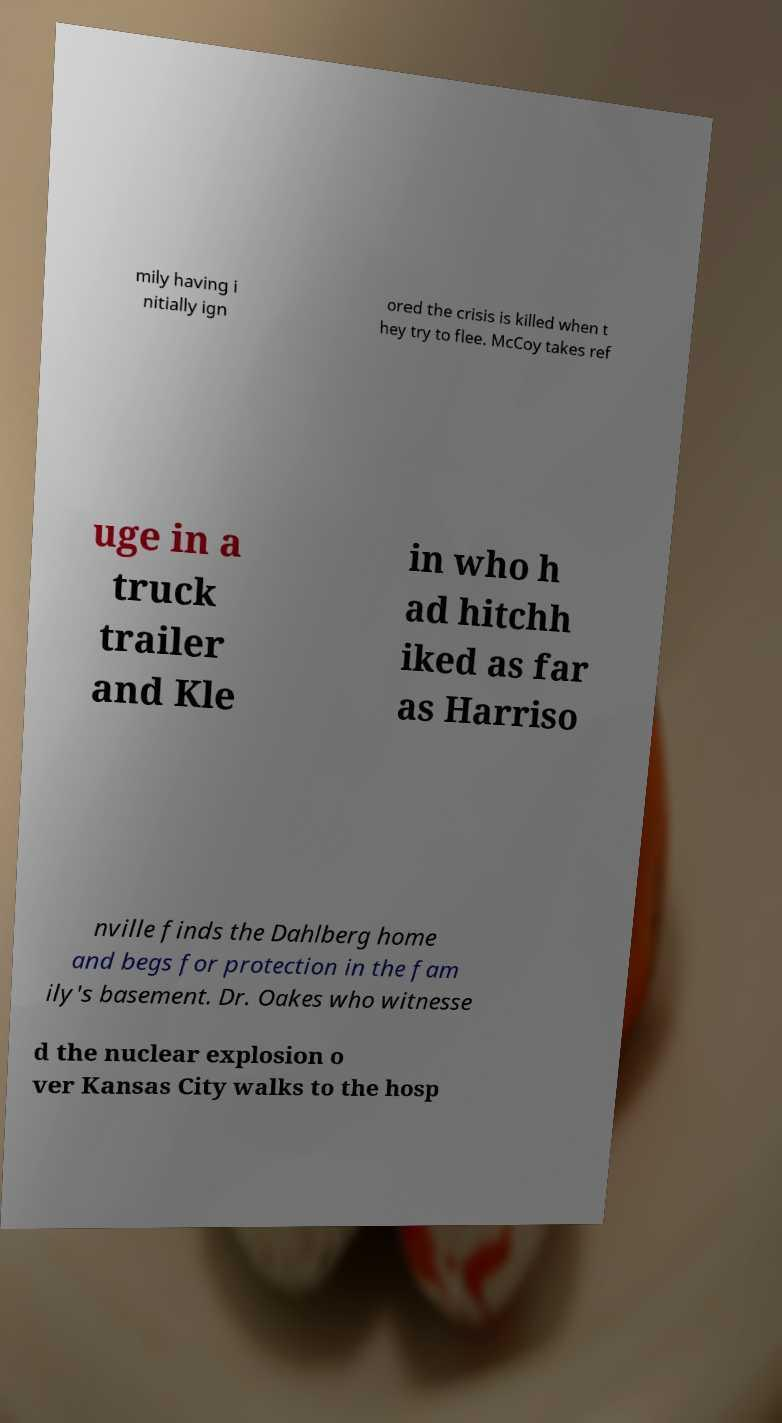For documentation purposes, I need the text within this image transcribed. Could you provide that? mily having i nitially ign ored the crisis is killed when t hey try to flee. McCoy takes ref uge in a truck trailer and Kle in who h ad hitchh iked as far as Harriso nville finds the Dahlberg home and begs for protection in the fam ily's basement. Dr. Oakes who witnesse d the nuclear explosion o ver Kansas City walks to the hosp 